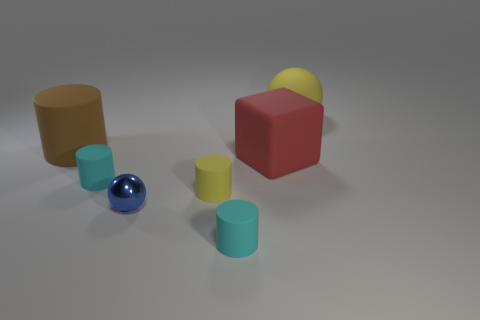Subtract all tiny yellow cylinders. How many cylinders are left? 3 Add 2 brown rubber things. How many objects exist? 9 Subtract all cyan cylinders. How many cylinders are left? 2 Subtract all blocks. How many objects are left? 6 Subtract 2 balls. How many balls are left? 0 Subtract all gray cubes. Subtract all red balls. How many cubes are left? 1 Subtract all red spheres. How many cyan cylinders are left? 2 Subtract all small yellow spheres. Subtract all cyan rubber cylinders. How many objects are left? 5 Add 7 large rubber cylinders. How many large rubber cylinders are left? 8 Add 6 small gray rubber cubes. How many small gray rubber cubes exist? 6 